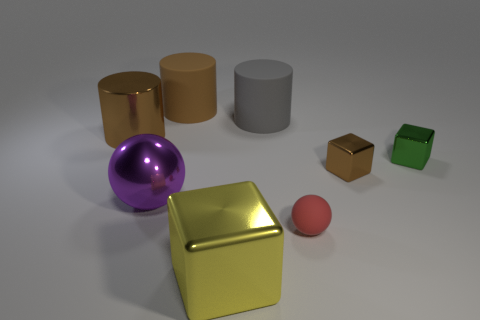Subtract all big yellow blocks. How many blocks are left? 2 Subtract all cubes. How many objects are left? 5 Subtract all red spheres. How many spheres are left? 1 Add 1 red rubber spheres. How many objects exist? 9 Subtract all purple cylinders. How many gray spheres are left? 0 Subtract all yellow objects. Subtract all large yellow cubes. How many objects are left? 6 Add 8 tiny red rubber things. How many tiny red rubber things are left? 9 Add 1 green shiny cubes. How many green shiny cubes exist? 2 Subtract 0 yellow cylinders. How many objects are left? 8 Subtract 1 cylinders. How many cylinders are left? 2 